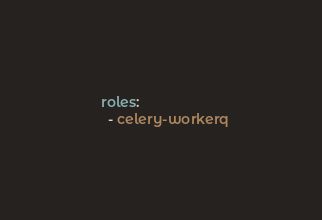Convert code to text. <code><loc_0><loc_0><loc_500><loc_500><_YAML_>  roles:
    - celery-workerq</code> 